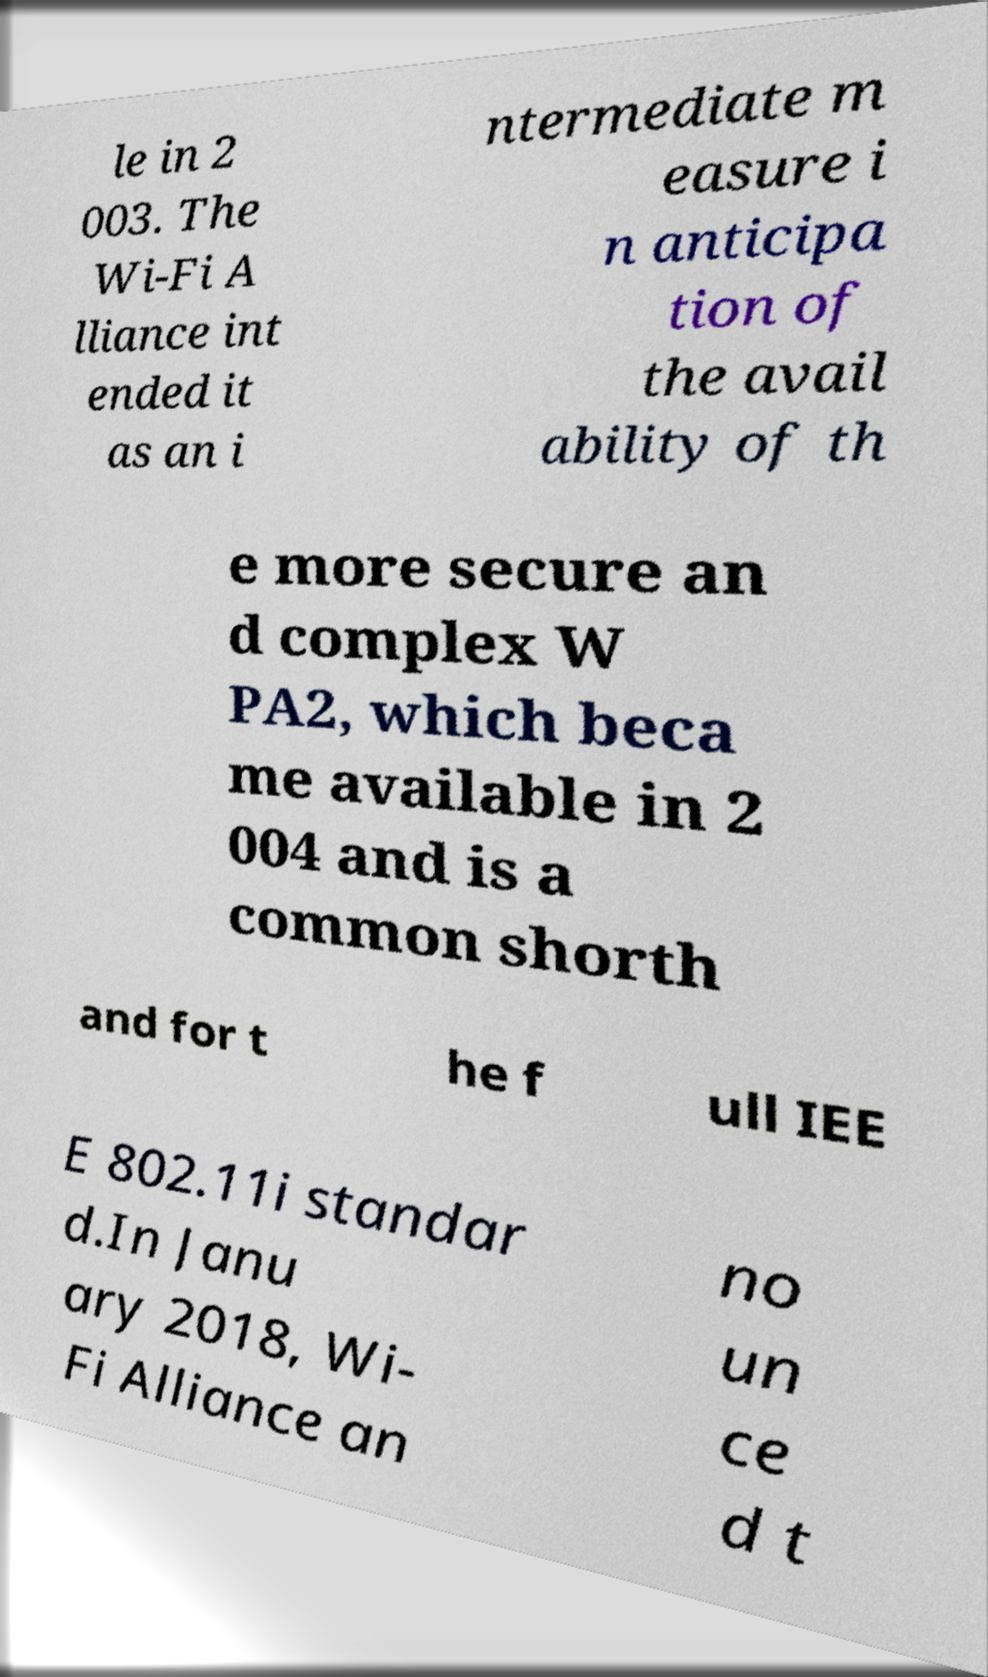Could you extract and type out the text from this image? le in 2 003. The Wi-Fi A lliance int ended it as an i ntermediate m easure i n anticipa tion of the avail ability of th e more secure an d complex W PA2, which beca me available in 2 004 and is a common shorth and for t he f ull IEE E 802.11i standar d.In Janu ary 2018, Wi- Fi Alliance an no un ce d t 